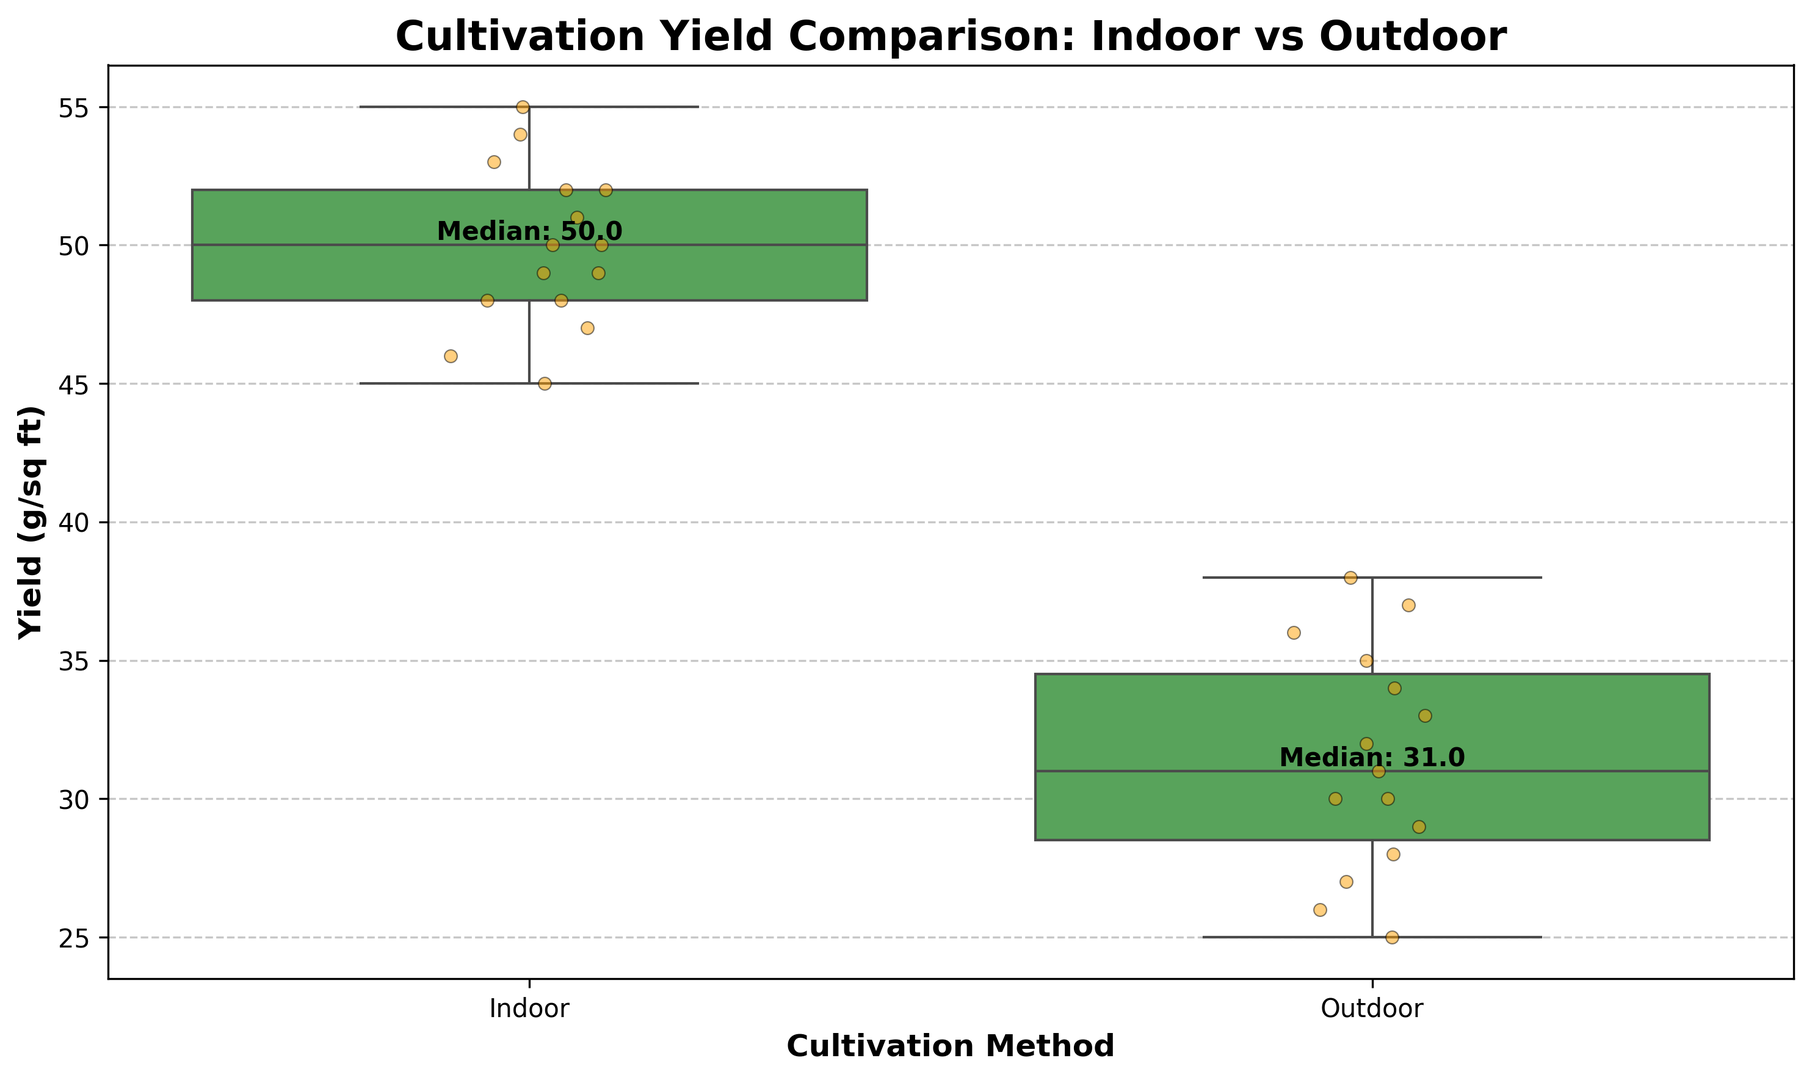How do the median yields compare between indoor and outdoor cultivation methods? The median yield for indoor cultivation is labeled as "Median: 50" next to the indoor box and the median yield for outdoor cultivation is labeled as "Median: 30" next to the outdoor box. Therefore, indoor cultivation has a higher median yield compared to outdoor cultivation.
Answer: Indoor has a higher median yield What is the range of the yield for outdoor cultivation? The range is determined by subtracting the minimum value from the maximum value. The highest point on the box plot for outdoor yield is 38 g/sq ft and the lowest is 25 g/sq ft. Therefore, the range is 38 - 25 = 13.
Answer: 13 g/sq ft Which cultivation method has a wider interquartile range (IQR)? The IQR can be visualized as the height of the box in each box plot, representing the middle 50% of the data. The indoor box is taller than the outdoor box, indicating that indoor cultivation has a wider IQR.
Answer: Indoor What is the maximum yield observed for indoor cultivation? The maximum value is represented by the top whisker of the indoor box plot, which reaches up to 55 g/sq ft.
Answer: 55 g/sq ft Are there any outliers in either of the cultivation methods? Outliers would be represented by points that lie outside the whiskers of the box plot. There are no points outside the whiskers for either indoor or outdoor cultivation, indicating no outliers.
Answer: No What is the difference between the median yields of indoor and outdoor cultivation? The medians are 50 g/sq ft for indoor and 30 g/sq ft for outdoor cultivation. The difference is 50 - 30 = 20 g/sq ft.
Answer: 20 g/sq ft Does indoor or outdoor cultivation show a higher variability in yield? Higher variability can be assessed by the range and the length of the whiskers. Indoor cultivation shows greater lengths in both respects, indicating higher variability.
Answer: Indoor How close are the lower quartiles of indoor and outdoor yields? The lower quartile of indoor cultivation (Q1) is the bottom edge of the indoor box, and the lower quartile for outdoor is the bottom edge of the outdoor box. Visually, the indoor Q1 is around 47 g/sq ft and the outdoor Q1 is around 27 g/sq ft, making the difference about 20 g/sq ft.
Answer: 20 g/sq ft 